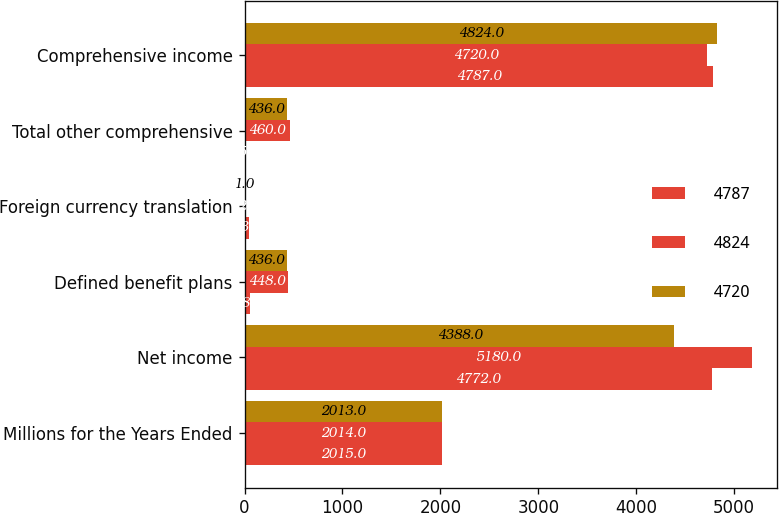Convert chart to OTSL. <chart><loc_0><loc_0><loc_500><loc_500><stacked_bar_chart><ecel><fcel>Millions for the Years Ended<fcel>Net income<fcel>Defined benefit plans<fcel>Foreign currency translation<fcel>Total other comprehensive<fcel>Comprehensive income<nl><fcel>4787<fcel>2015<fcel>4772<fcel>58<fcel>43<fcel>15<fcel>4787<nl><fcel>4824<fcel>2014<fcel>5180<fcel>448<fcel>12<fcel>460<fcel>4720<nl><fcel>4720<fcel>2013<fcel>4388<fcel>436<fcel>1<fcel>436<fcel>4824<nl></chart> 